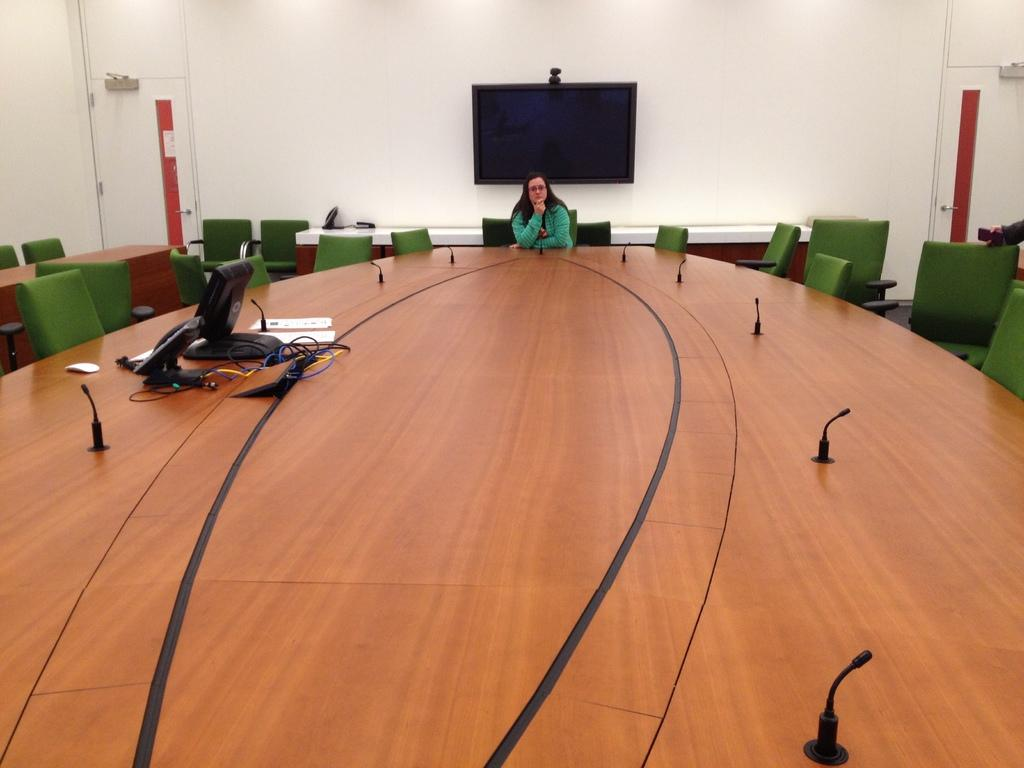What can be seen in the background of the image? In the background of the image, there is a screen, a wall, and doors. What objects are present on the table in the image? On the table, there are microphones and electronic devices. What type of furniture is visible in the image? Chairs are visible in the image. What is the woman in the image doing? The woman is sitting on a chair. Can you see any fangs in the image? There are no fangs present in the image. Is the woman in the image painting her nails? There is no indication of nail painting in the image. 